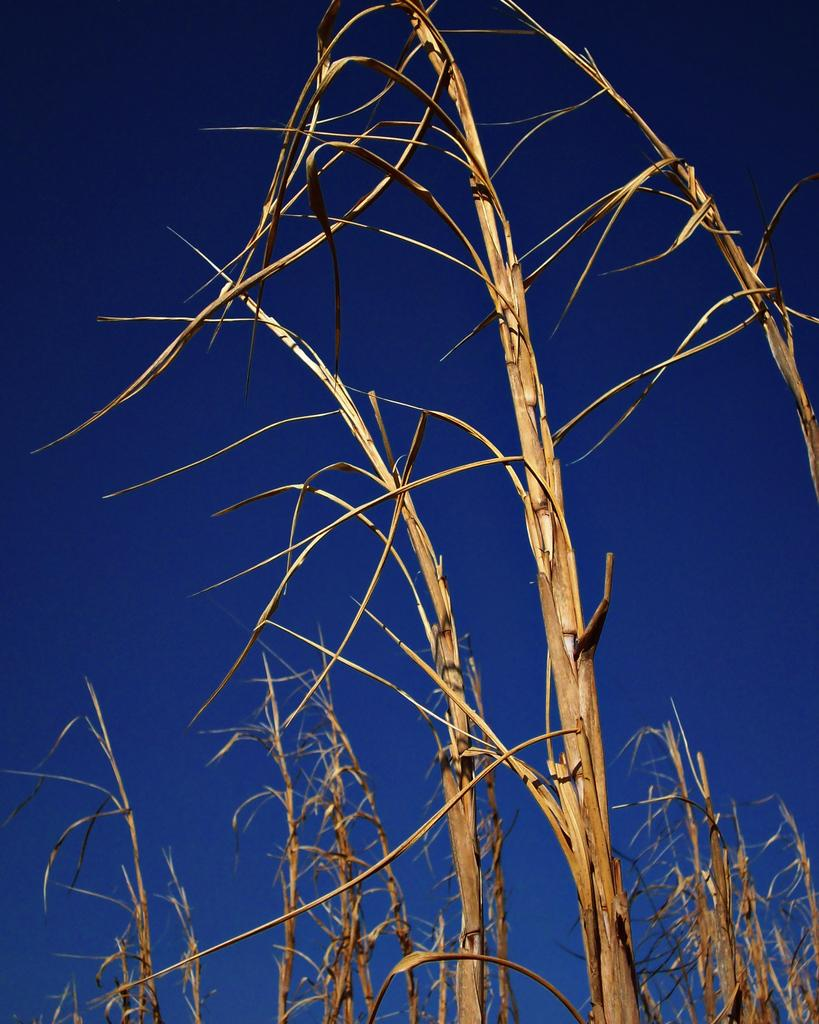What type of living organisms can be seen in the image? Plants can be seen in the image. What part of the natural environment is visible in the image? The sky is visible in the background of the image. What shape is the plot of land occupied by the plants in the image? There is no indication of the shape of the land in the image, as it only shows plants and the sky. 